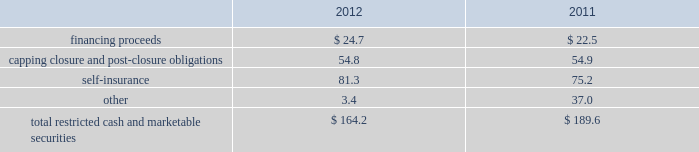Republic services , inc .
Notes to consolidated financial statements 2014 ( continued ) the letters of credit use $ 909.4 million and $ 950.2 million as of december 31 , 2012 and 2011 , respectively , of availability under our credit facilities .
Surety bonds expire on various dates through 2026 .
These financial instruments are issued in the normal course of business and are not debt .
Because we currently have no liability for this financial assurance , it is not reflected in our consolidated balance sheets .
However , we have recorded capping , closure and post-closure obligations and self-insurance reserves as they are incurred .
The underlying financial assurance obligations , in excess of those already reflected in our consolidated balance sheets , would be recorded if it is probable that we would be unable to fulfill our related obligations .
We do not expect this to occur .
Our restricted cash and marketable securities deposits include , among other things , restricted cash and marketable securities held for capital expenditures under certain debt facilities , and restricted cash and marketable securities pledged to regulatory agencies and governmental entities as financial guarantees of our performance related to our final capping , closure and post-closure obligations at our landfills .
The table summarizes our restricted cash and marketable securities as of december 31: .
We own a 19.9% ( 19.9 % ) interest in a company that , among other activities , issues financial surety bonds to secure capping , closure and post-closure obligations for companies operating in the solid waste industry .
We account for this investment under the cost method of accounting .
There have been no identified events or changes in circumstances that may have a significant adverse effect on the recoverability of the investment .
This investee company and the parent company of the investee had written surety bonds for us relating primarily to our landfill operations for capping , closure and post-closure , of which $ 1152.1 million was outstanding as of december 31 , 2012 .
Our reimbursement obligations under these bonds are secured by an indemnity agreement with the investee and letters of credit totaling $ 23.4 million and $ 45.0 million as of december 31 , 2012 and 2011 .
Off-balance sheet arrangements we have no off-balance sheet debt or similar obligations , other than operating leases and the financial assurances discussed above , which are not classified as debt .
We have no transactions or obligations with related parties that are not disclosed , consolidated into or reflected in our reported financial position or results of operations .
We have not guaranteed any third-party debt .
Guarantees we enter into contracts in the normal course of business that include indemnification clauses .
Indemnifications relating to known liabilities are recorded in the consolidated financial statements based on our best estimate of required future payments .
Certain of these indemnifications relate to contingent events or occurrences , such as the imposition of additional taxes due to a change in the tax law or adverse interpretation of the tax law , and indemnifications made in divestiture agreements where we indemnify the buyer for liabilities that relate to our activities prior to the divestiture and that may become known in the future .
We do not believe that these contingent obligations will have a material effect on our consolidated financial position , results of operations or cash flows. .
What was the percentage decline in the total restricted cash and marketable securities from 2011 to 2012? 
Rationale: the percentage change is the change from one period to the next divide by the earliest period
Computations: ((164.2 - 189.6) / 189.6)
Answer: -0.13397. 